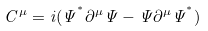Convert formula to latex. <formula><loc_0><loc_0><loc_500><loc_500>C ^ { \mu } = i ( \Psi ^ { ^ { * } } \partial ^ { \mu } \Psi - \Psi \partial ^ { \mu } \Psi ^ { ^ { * } } )</formula> 